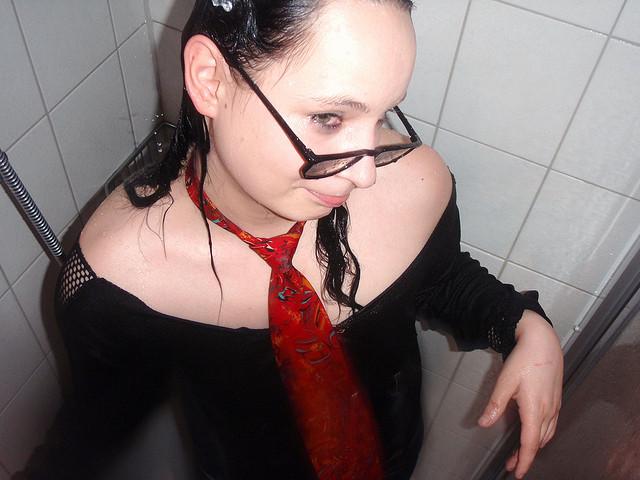What is around this ladies neck?
Keep it brief. Tie. Is she wearing glasses?
Concise answer only. Yes. If the her husband walked in and saw her wearing his tie this way would he be mad or excited?
Answer briefly. Mad. 